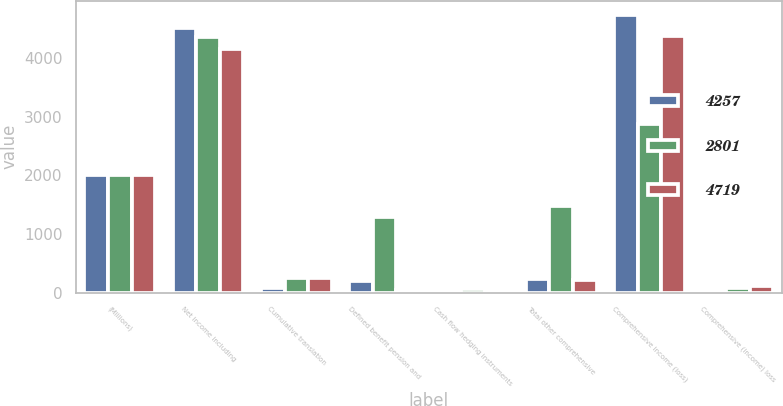Convert chart to OTSL. <chart><loc_0><loc_0><loc_500><loc_500><stacked_bar_chart><ecel><fcel>(Millions)<fcel>Net income including<fcel>Cumulative translation<fcel>Defined benefit pension and<fcel>Cash flow hedging instruments<fcel>Total other comprehensive<fcel>Comprehensive income (loss)<fcel>Comprehensive (income) loss<nl><fcel>4257<fcel>2012<fcel>4511<fcel>71<fcel>201<fcel>45<fcel>231<fcel>4742<fcel>23<nl><fcel>2801<fcel>2011<fcel>4357<fcel>250<fcel>1280<fcel>54<fcel>1476<fcel>2881<fcel>80<nl><fcel>4719<fcel>2010<fcel>4163<fcel>244<fcel>42<fcel>4<fcel>209<fcel>4372<fcel>115<nl></chart> 